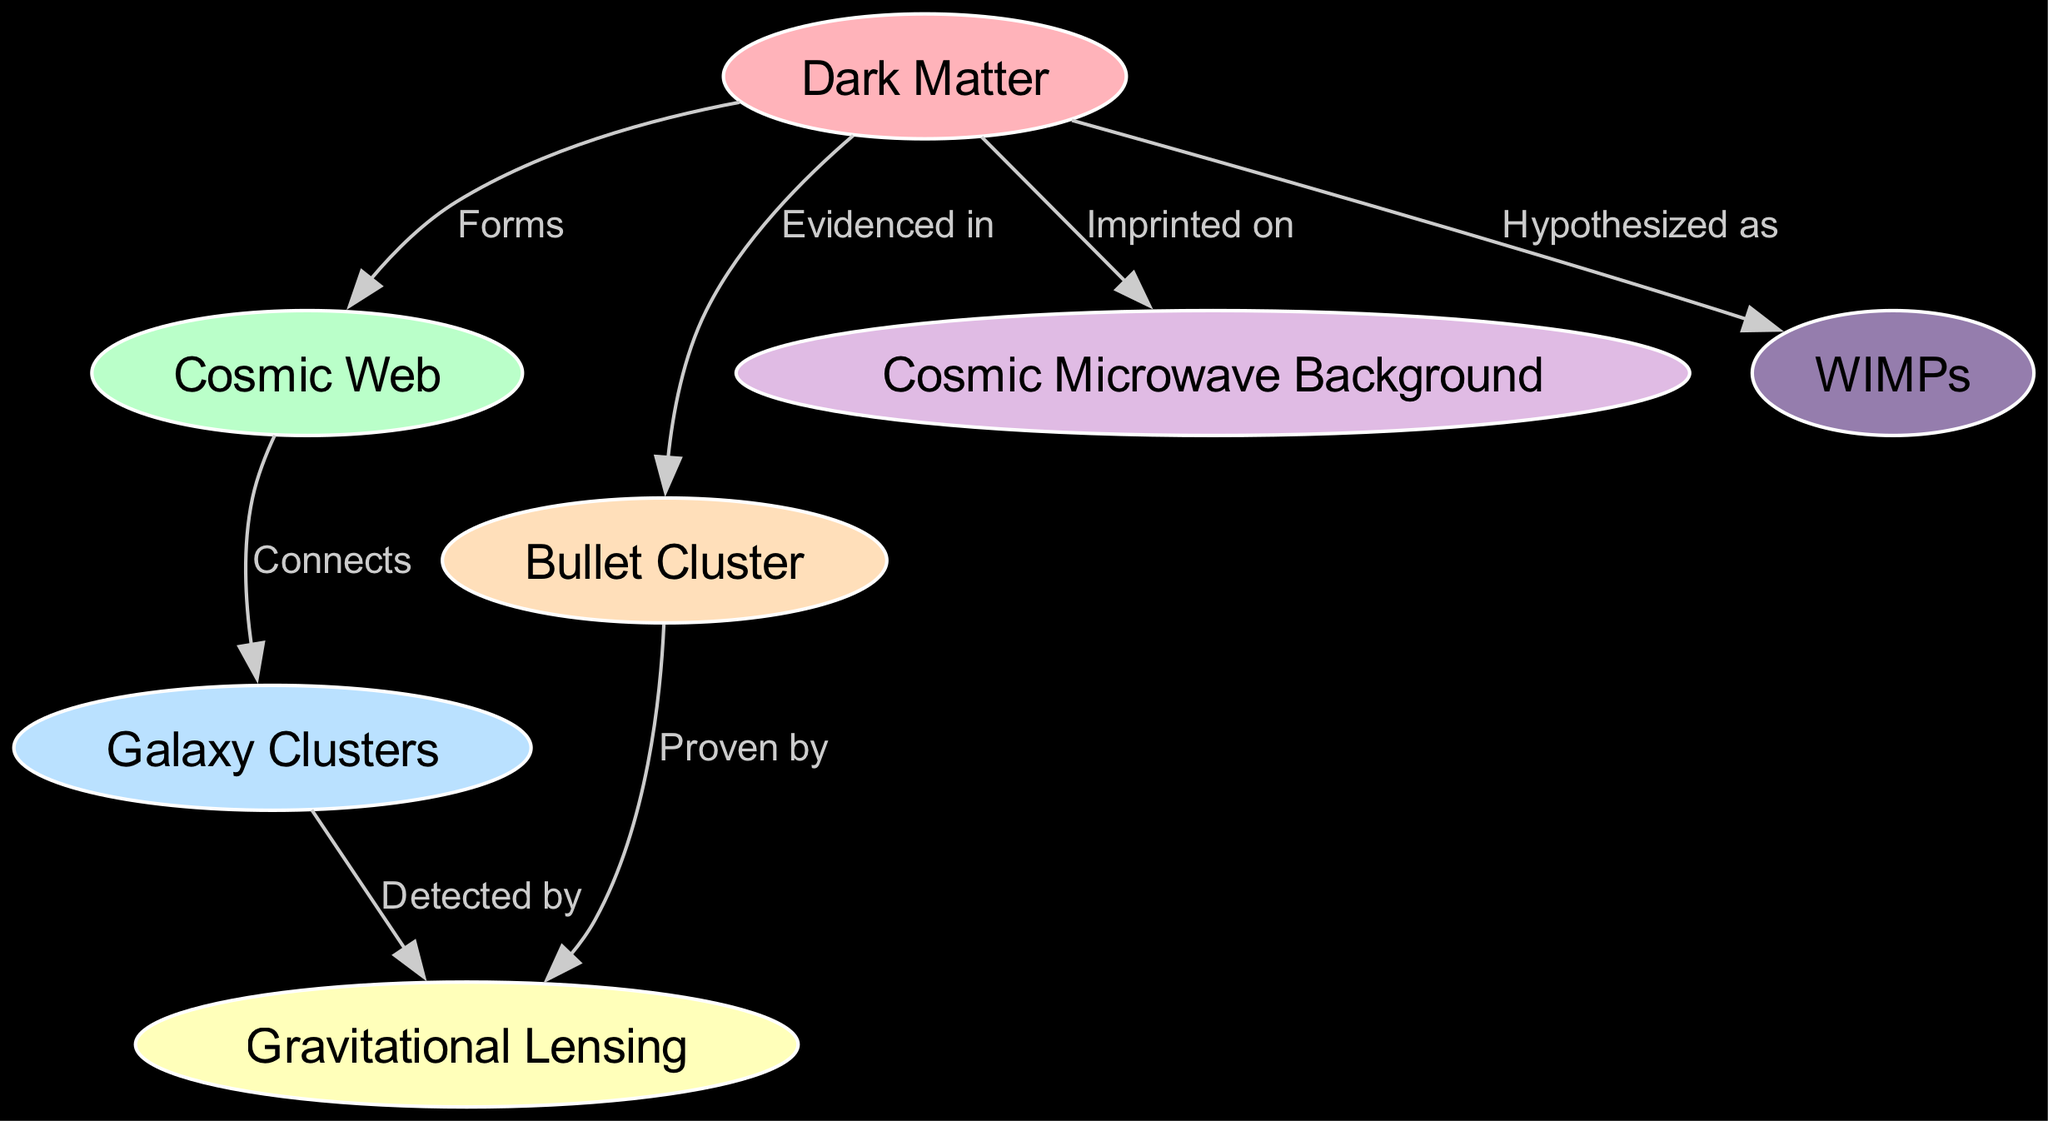What is the label of the node representing invisible material? The node dedicated to the invisible material is labeled "Dark Matter," as shown in the diagram.
Answer: Dark Matter How many nodes are present in the diagram? Counting all unique entities in the diagram, there is a total of seven nodes represented.
Answer: 7 What relationship connects "Cosmic Web" and "Galaxy Clusters"? The relationship connecting these two nodes is labeled "Connects," indicating that the Cosmic Web links various Galaxy Clusters together.
Answer: Connects What is detected by gravitational lensing? The diagram indicates that gravitational lensing is used to detect "Galaxy Clusters," showcasing the connection and relationship between these entities.
Answer: Galaxy Clusters What is imprinted on the cosmic microwave background? The diagram specifically mentions that "Dark Matter" is what leaves its imprint on the Cosmic Microwave Background, indicating a relationship.
Answer: Dark Matter Which node provides direct evidence of dark matter? The "Bullet Cluster" node specifically states that it provides direct evidence of dark matter, highlighting its significance in the diagram.
Answer: Bullet Cluster What type of particles is hypothesized as a candidate for dark matter? The diagram indicates that "WIMPs," or Weakly Interacting Massive Particles, are hypothesized as a leading candidate for dark matter.
Answer: WIMPs Which node is proven by the gravitational lensing relationship? The relationship specified indicates that "Bullet Cluster" is proven by gravitational lensing, confirming the evidence of dark matter.
Answer: Bullet Cluster What larger structure does dark matter form according to the diagram? The diagram identifies that dark matter "Forms" the "Cosmic Web," establishing its role in the structure of the universe.
Answer: Cosmic Web 